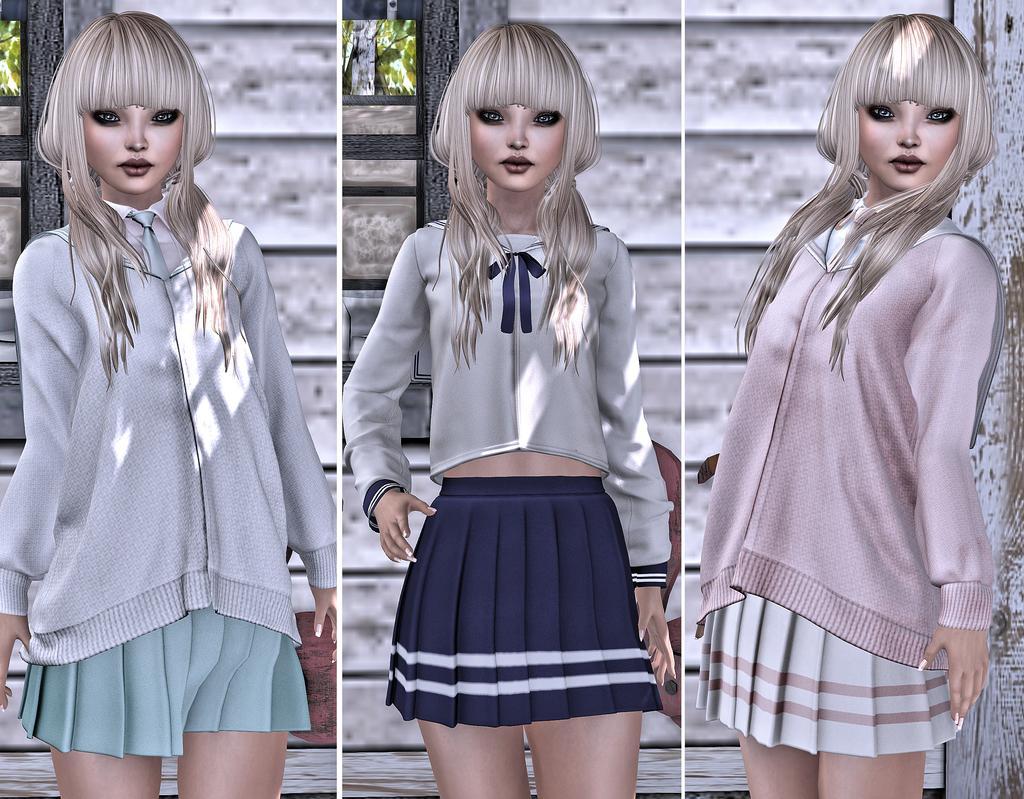Can you describe this image briefly? In this picture we can see three collage photos and edited images of the three dolls. Behind there is a wooden panel wall. 